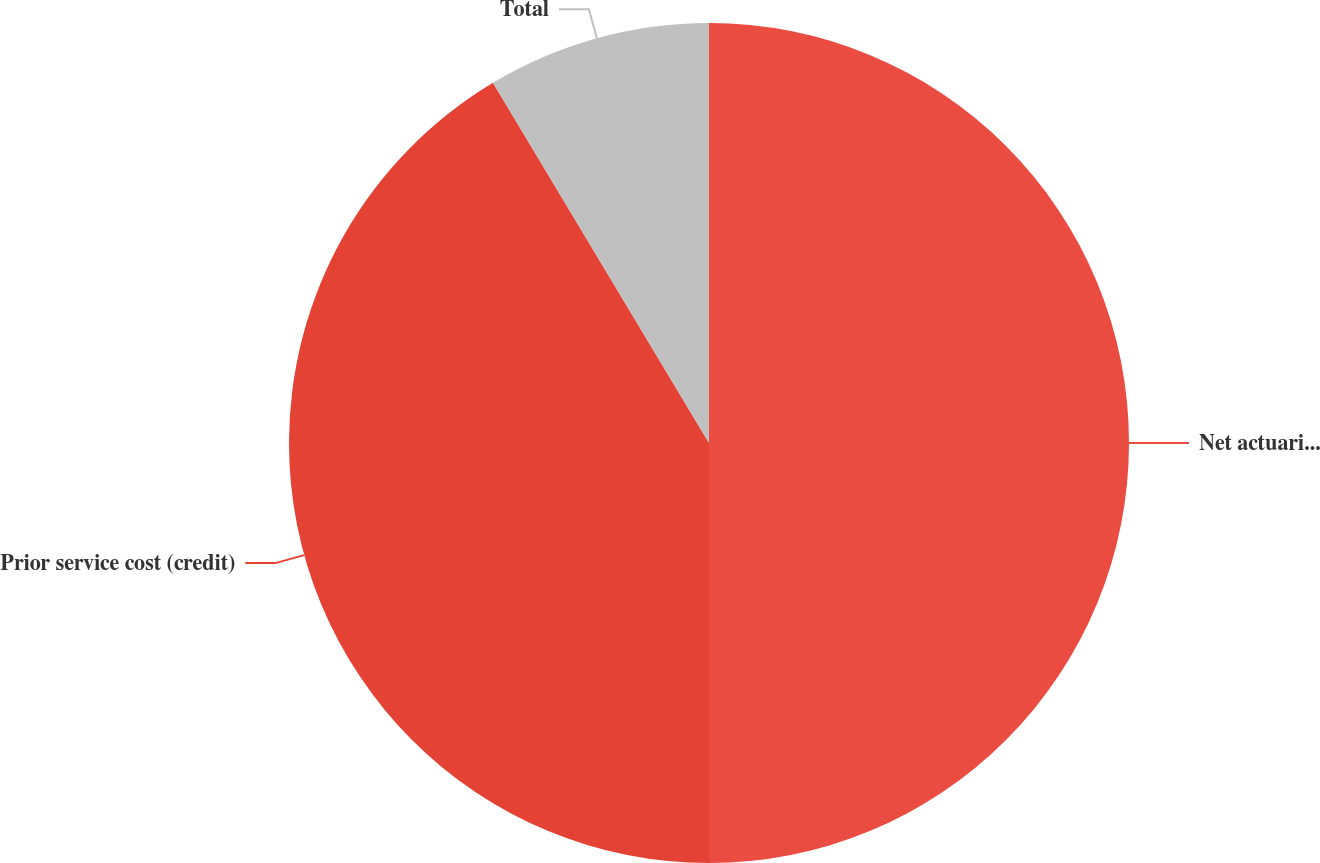Convert chart to OTSL. <chart><loc_0><loc_0><loc_500><loc_500><pie_chart><fcel>Net actuarial loss<fcel>Prior service cost (credit)<fcel>Total<nl><fcel>50.0%<fcel>41.4%<fcel>8.6%<nl></chart> 